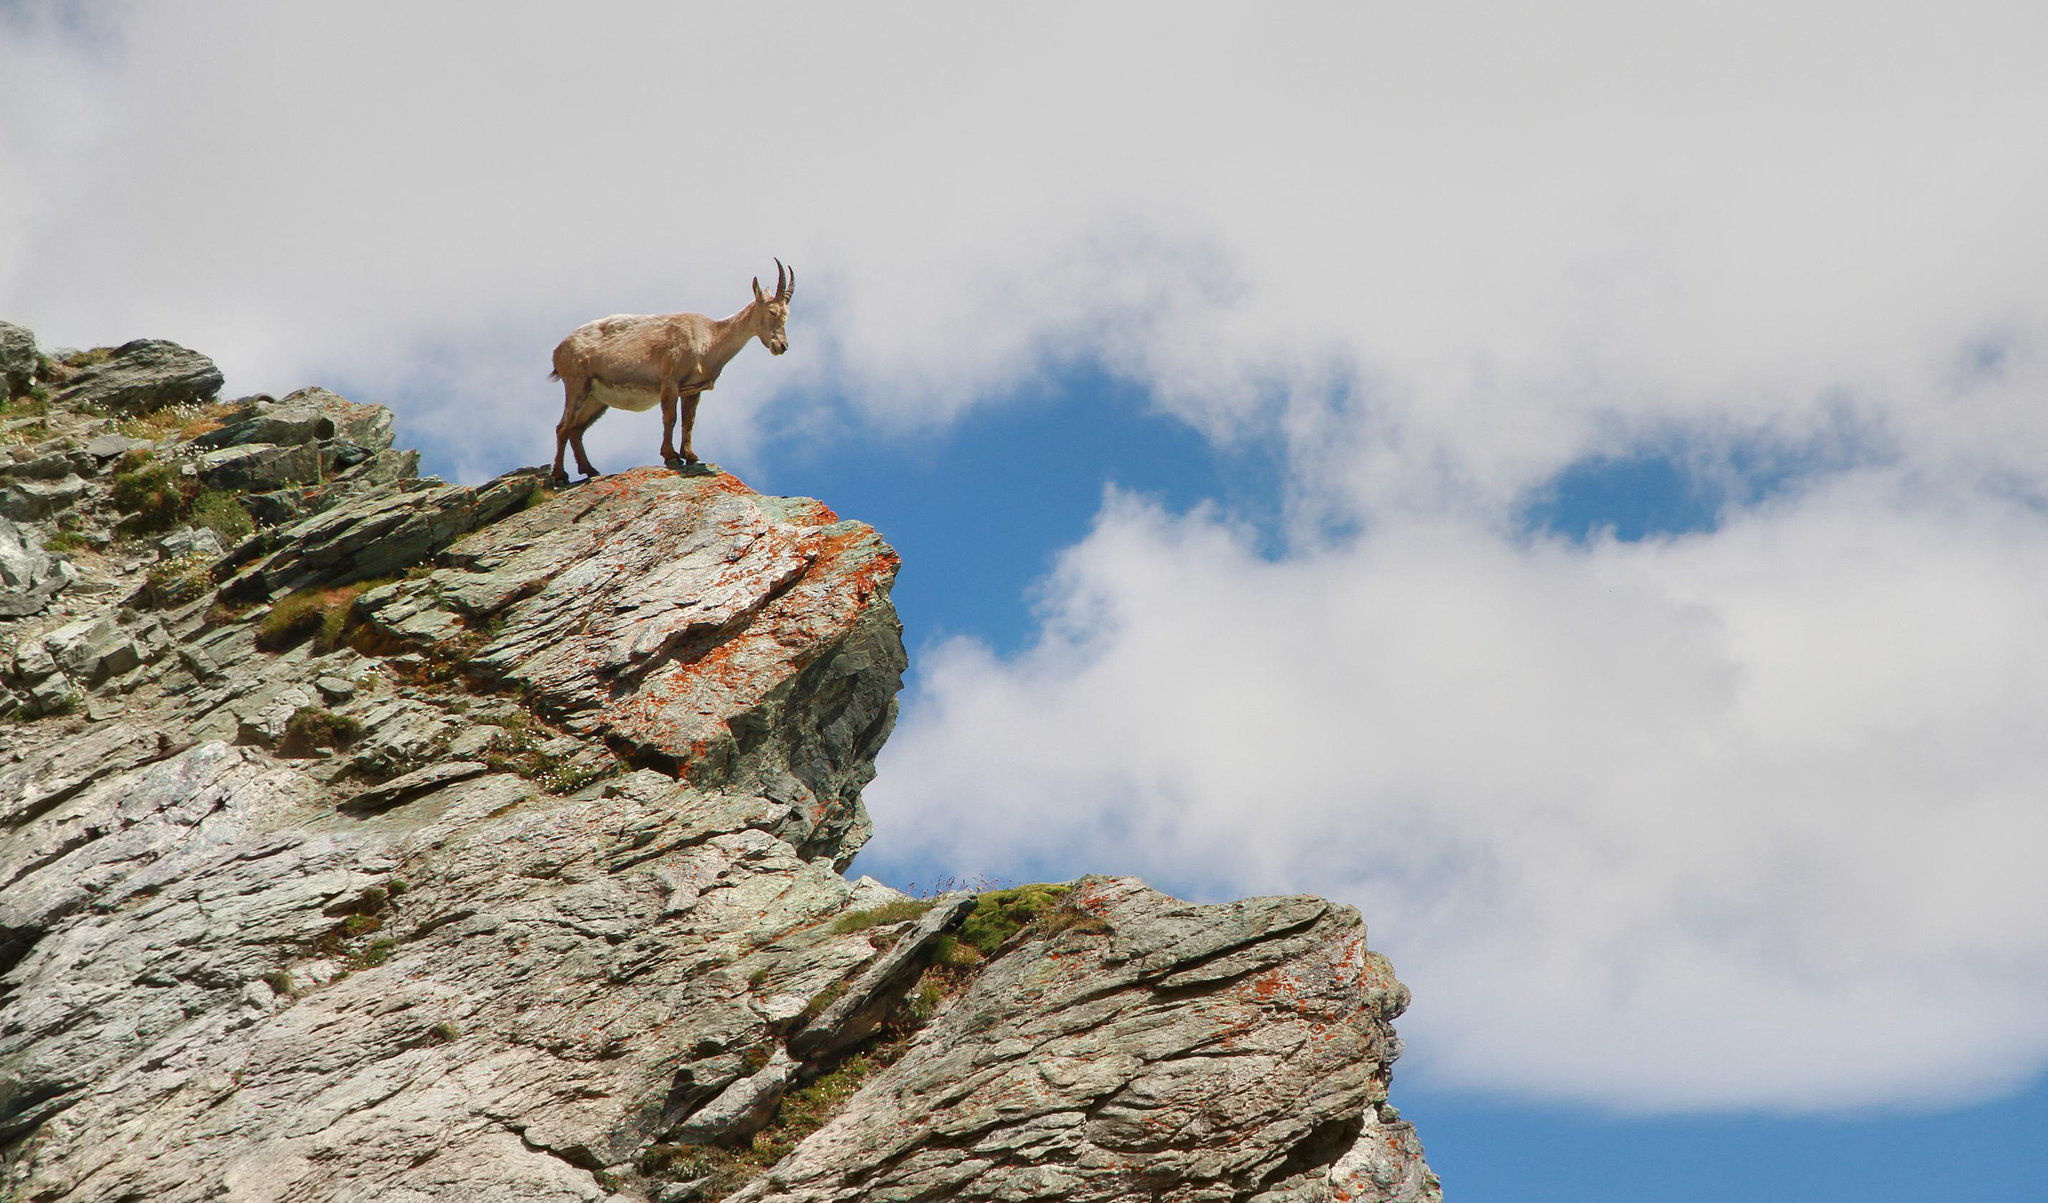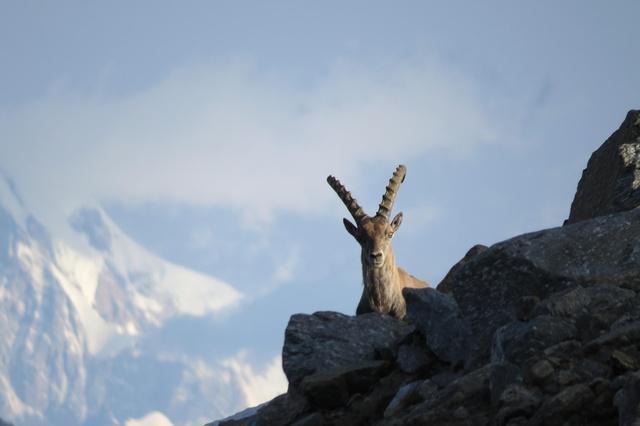The first image is the image on the left, the second image is the image on the right. Examine the images to the left and right. Is the description "The right image contains a horned animal looking at the camera." accurate? Answer yes or no. Yes. The first image is the image on the left, the second image is the image on the right. For the images shown, is this caption "The ram/goat on the left is overlooking a jump." true? Answer yes or no. Yes. 